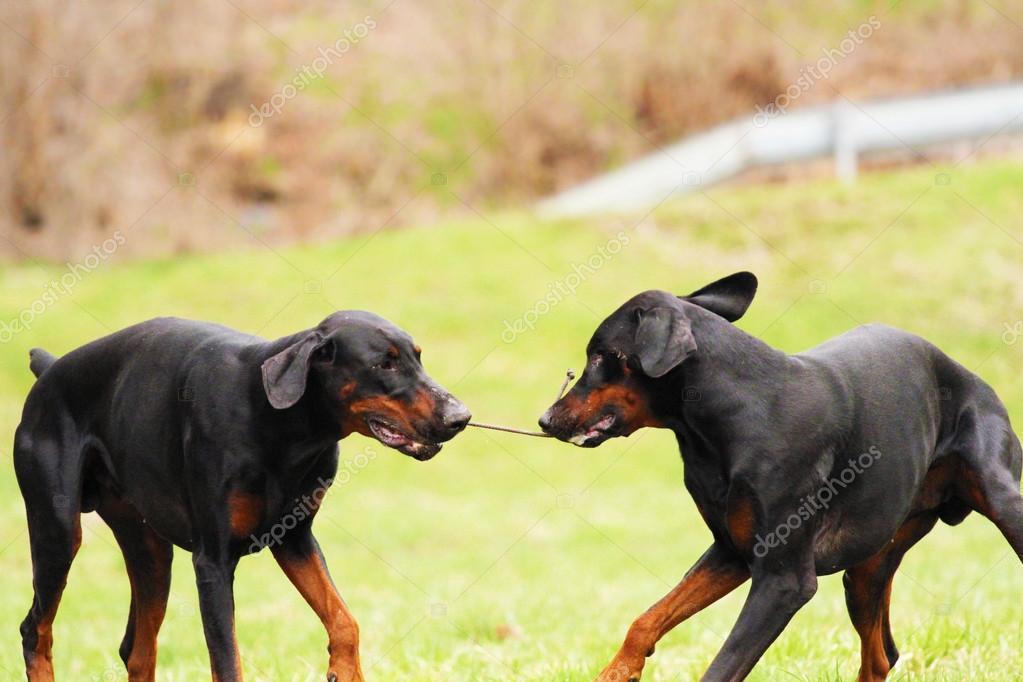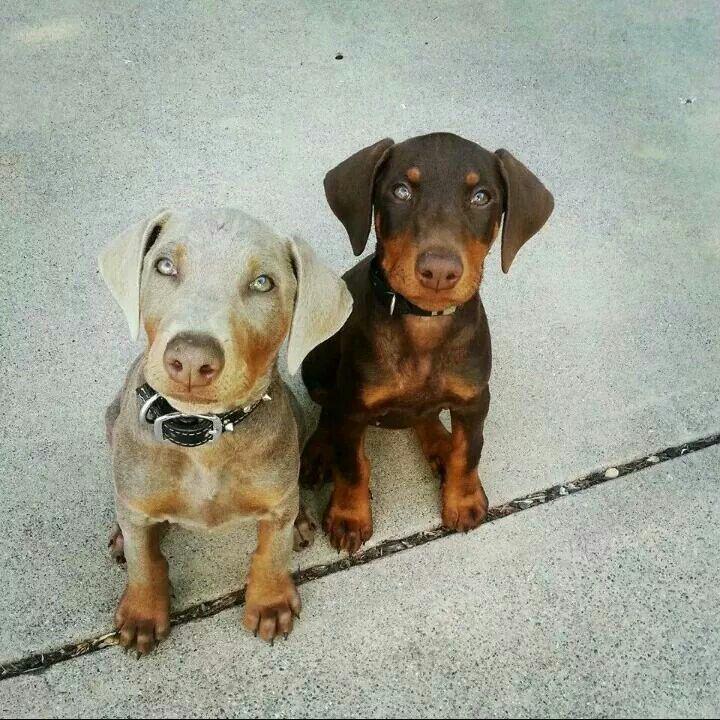The first image is the image on the left, the second image is the image on the right. Considering the images on both sides, is "Two dogs are sitting in the grass in the image on the right." valid? Answer yes or no. No. The first image is the image on the left, the second image is the image on the right. Considering the images on both sides, is "Two doberman with erect, pointy ears are facing forward and posed side-by-side in the right image." valid? Answer yes or no. No. 